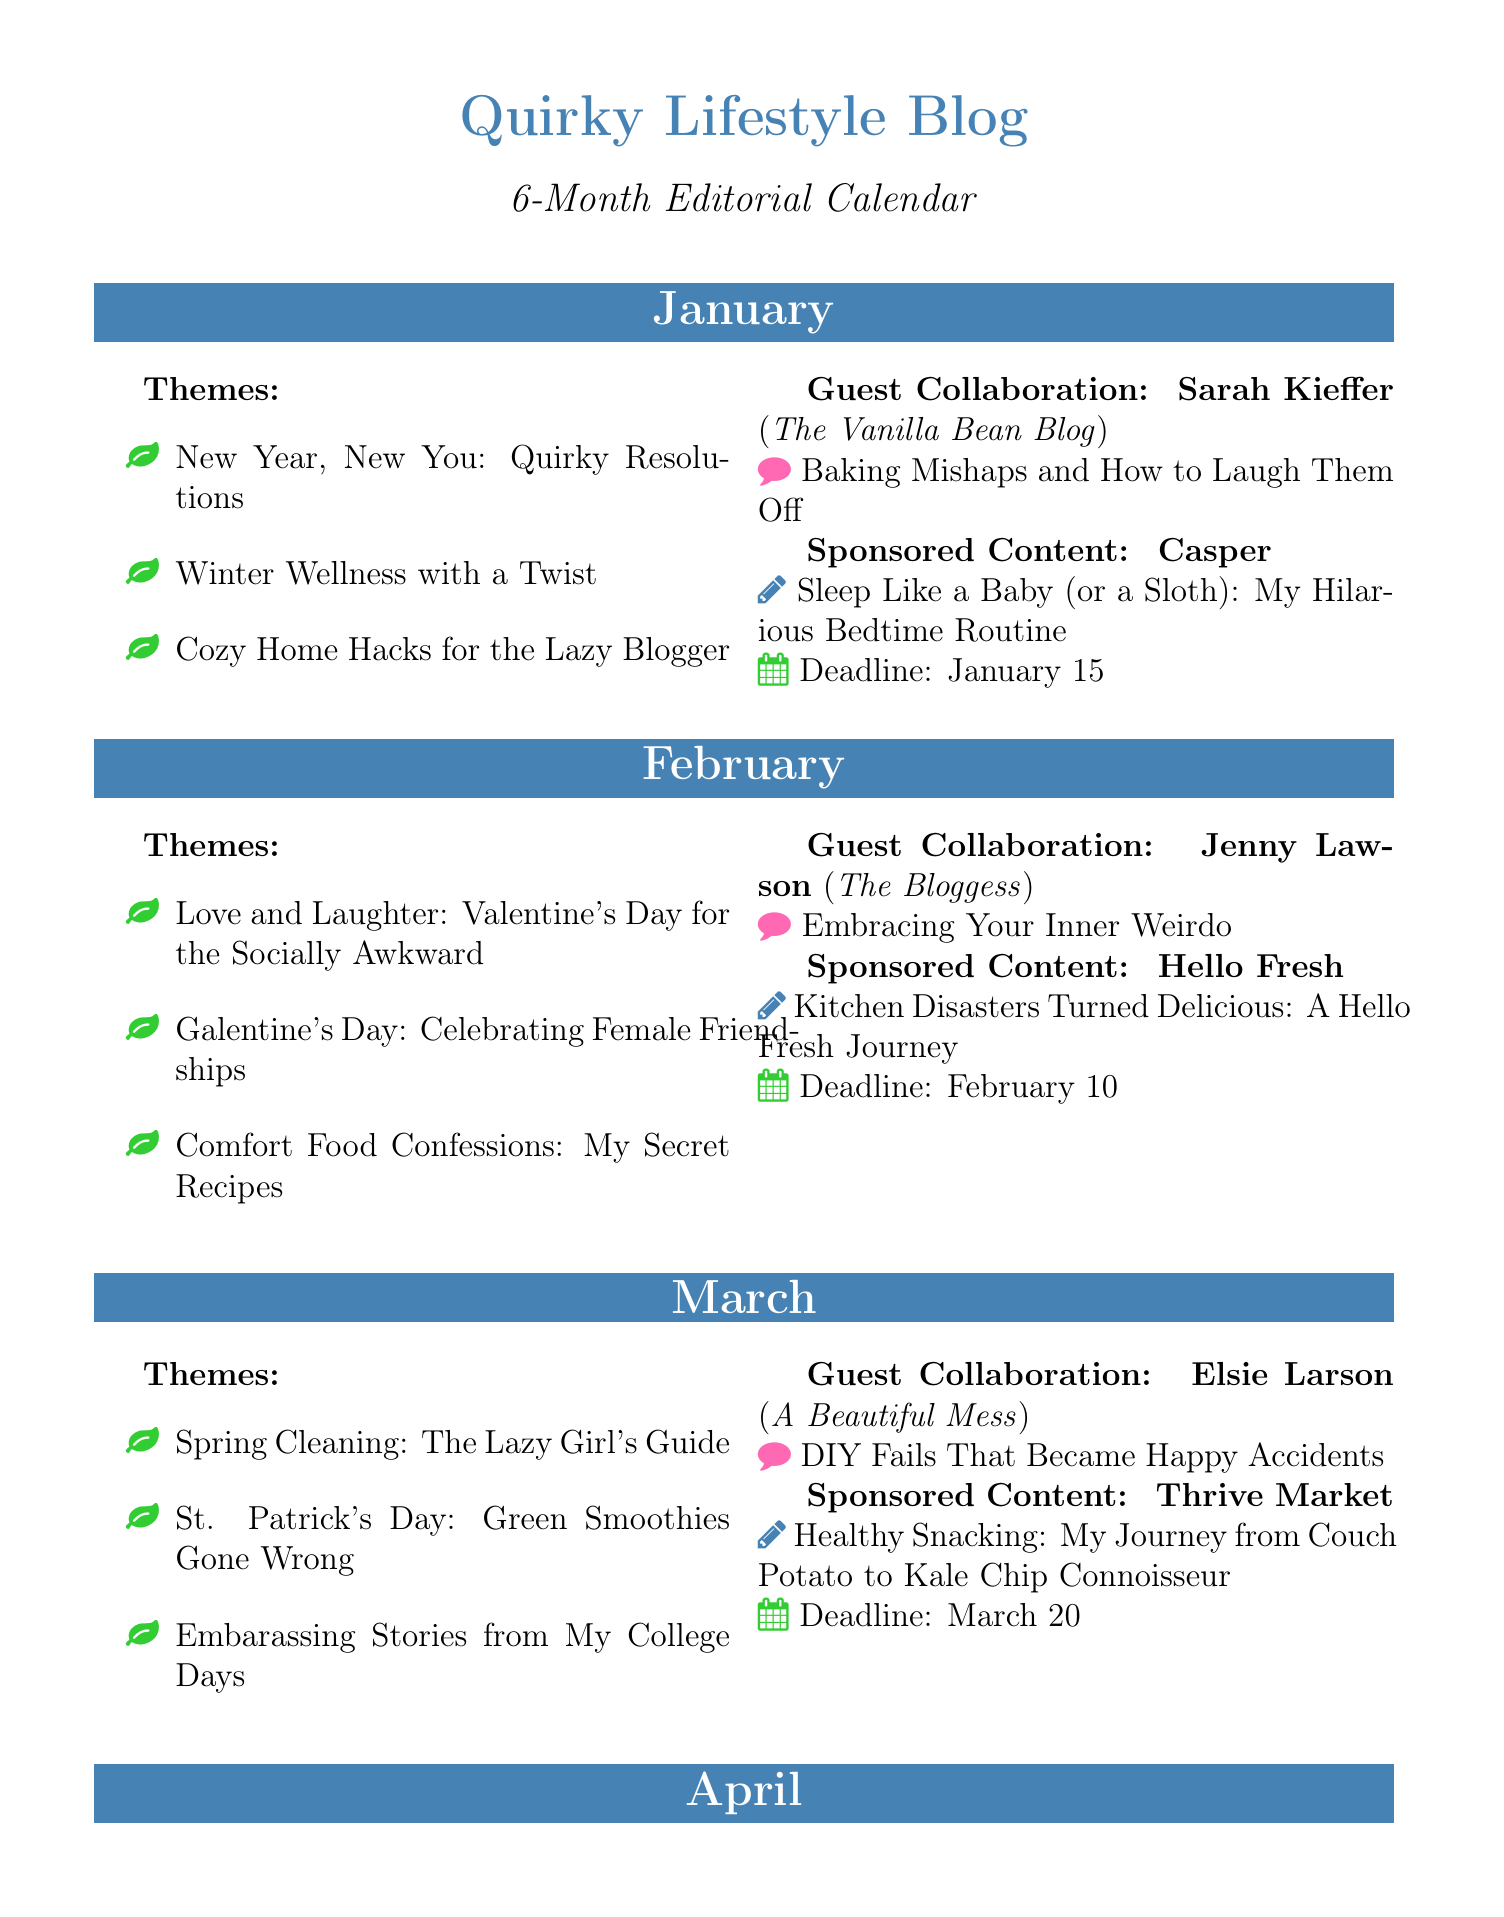What are the themes for June? The themes for June include summer-related content focused on leisure and humorous topics.
Answer: Summer Body Ready? More Like Summer Netflix Binge, Father's Day: Dad Jokes That Make You Groan, Staycation Ideas for the Lazy Traveler Who collaborated with you in May? The guest collaboration details for May list the collaborator's name and their blog.
Answer: Jenna Kutcher What is the deadline for sponsored content in April? The deadline for sponsored content in April is explicitly mentioned in the document.
Answer: April 5 What is the main topic of Sarah Kieffer's collaboration? The collaboration topic with Sarah Kieffer provides insight into the humorous aspect of baking.
Answer: Baking Mishaps and How to Laugh Them Off How many themes are listed for February? The number of themes for February can be determined by counting them in the document.
Answer: 3 Which brand is associated with the May sponsored content? The document specifies the brand associated with May's sponsored content.
Answer: Book of the Month What topic emphasizes summer humor in June? The document highlights a humorous take on summer in June's theme list.
Answer: Summer Body Ready? More Like Summer Netflix Binge Which guest collaboration discusses travel mishaps? The topic of the collaboration from April focuses on travel-related humor.
Answer: Travel Mishaps and How to Laugh Them Off 